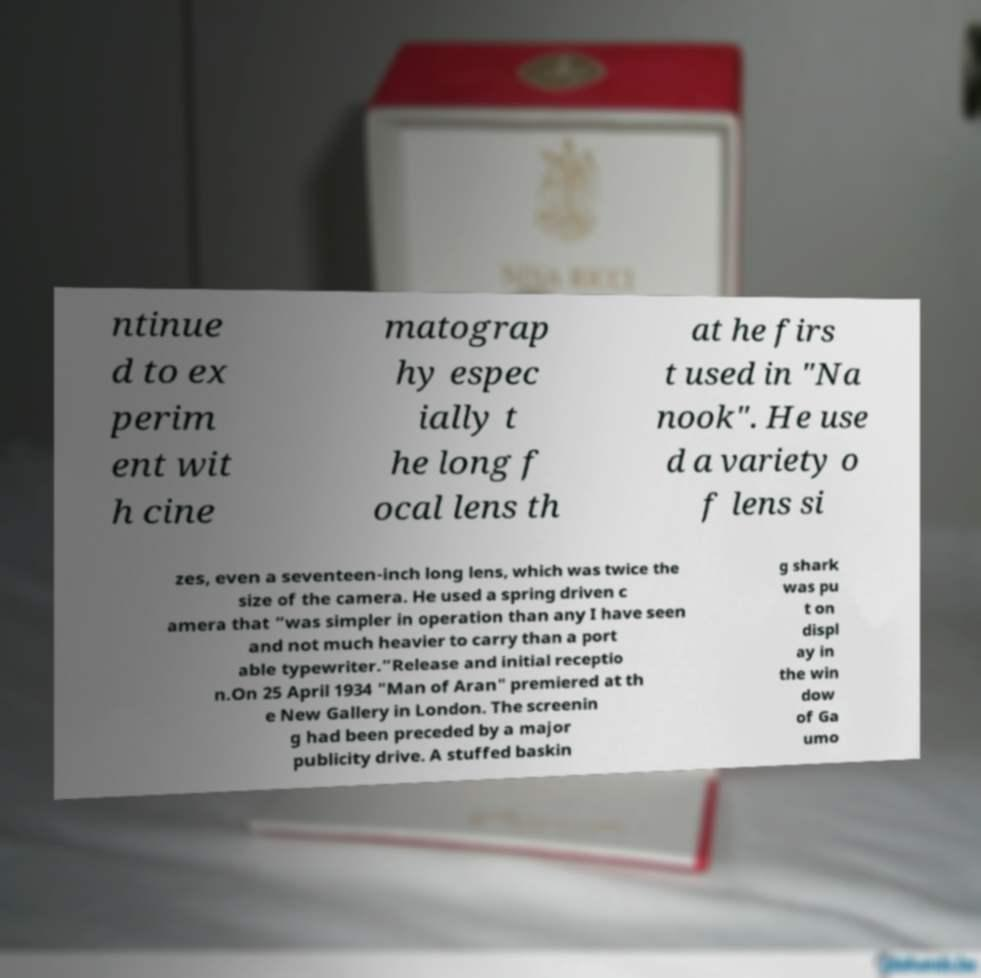Could you assist in decoding the text presented in this image and type it out clearly? ntinue d to ex perim ent wit h cine matograp hy espec ially t he long f ocal lens th at he firs t used in "Na nook". He use d a variety o f lens si zes, even a seventeen-inch long lens, which was twice the size of the camera. He used a spring driven c amera that “was simpler in operation than any I have seen and not much heavier to carry than a port able typewriter.”Release and initial receptio n.On 25 April 1934 "Man of Aran" premiered at th e New Gallery in London. The screenin g had been preceded by a major publicity drive. A stuffed baskin g shark was pu t on displ ay in the win dow of Ga umo 